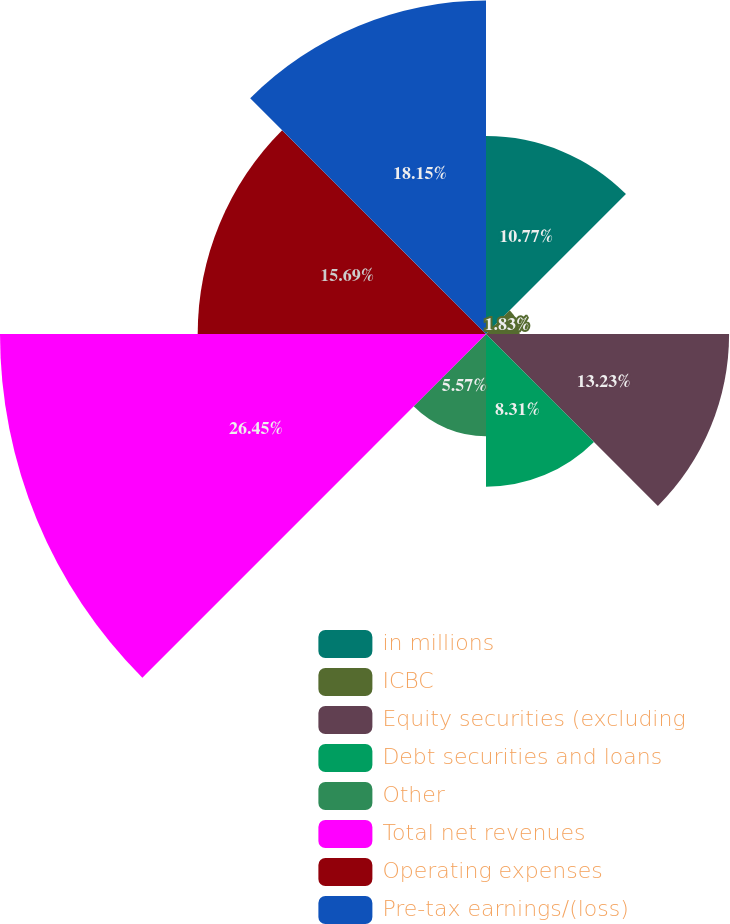Convert chart. <chart><loc_0><loc_0><loc_500><loc_500><pie_chart><fcel>in millions<fcel>ICBC<fcel>Equity securities (excluding<fcel>Debt securities and loans<fcel>Other<fcel>Total net revenues<fcel>Operating expenses<fcel>Pre-tax earnings/(loss)<nl><fcel>10.77%<fcel>1.83%<fcel>13.23%<fcel>8.31%<fcel>5.57%<fcel>26.45%<fcel>15.69%<fcel>18.15%<nl></chart> 